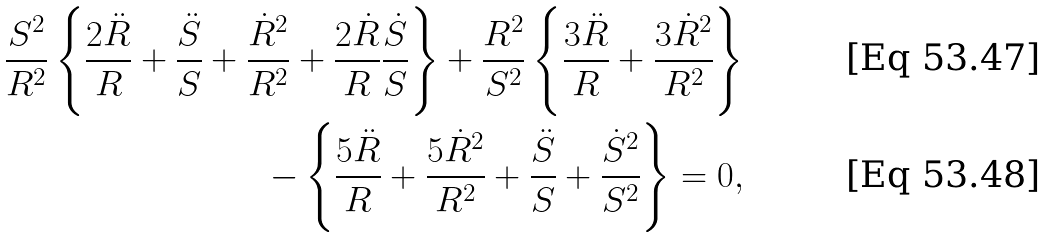Convert formula to latex. <formula><loc_0><loc_0><loc_500><loc_500>\frac { S ^ { 2 } } { R ^ { 2 } } \left \{ \frac { 2 \ddot { R } } { R } + \frac { \ddot { S } } { S } + \frac { \dot { R } ^ { 2 } } { R ^ { 2 } } + \frac { 2 \dot { R } } { R } \frac { \dot { S } } { S } \right \} + \frac { R ^ { 2 } } { S ^ { 2 } } \left \{ \frac { 3 \ddot { R } } { R } + \frac { 3 \dot { R } ^ { 2 } } { R ^ { 2 } } \right \} \\ - \left \{ \frac { 5 \ddot { R } } { R } + \frac { 5 \dot { R } ^ { 2 } } { R ^ { 2 } } + \frac { \ddot { S } } { S } + \frac { \dot { S } ^ { 2 } } { S ^ { 2 } } \right \} = 0 ,</formula> 